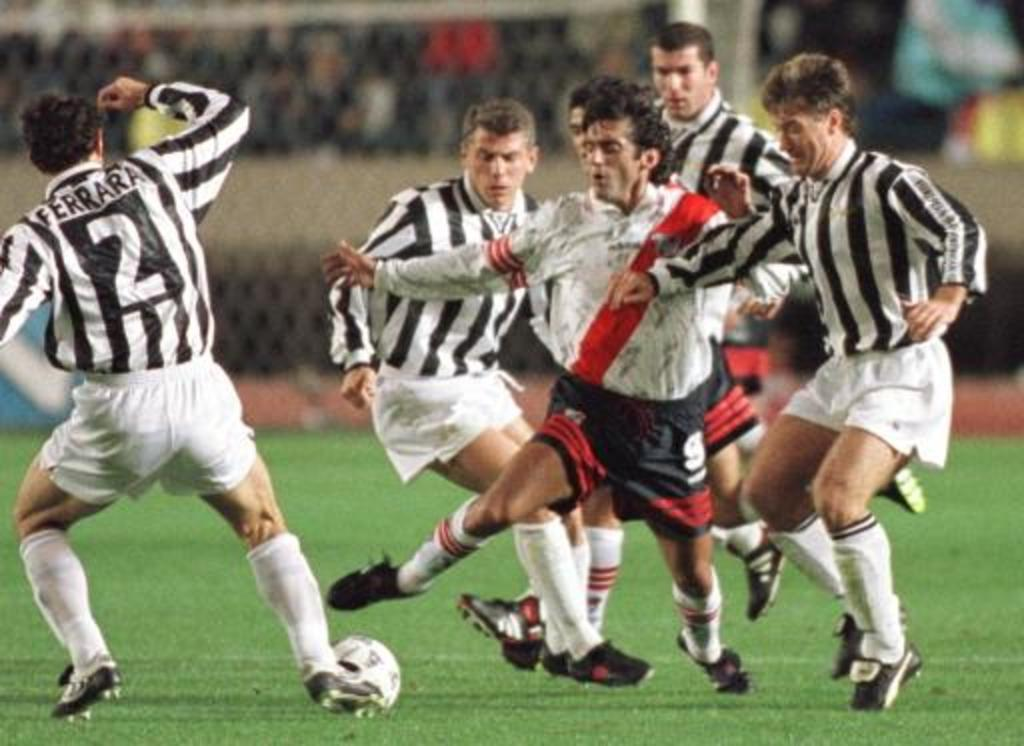<image>
Describe the image concisely. Player number 2 on this soccer team is named Ferrara. 